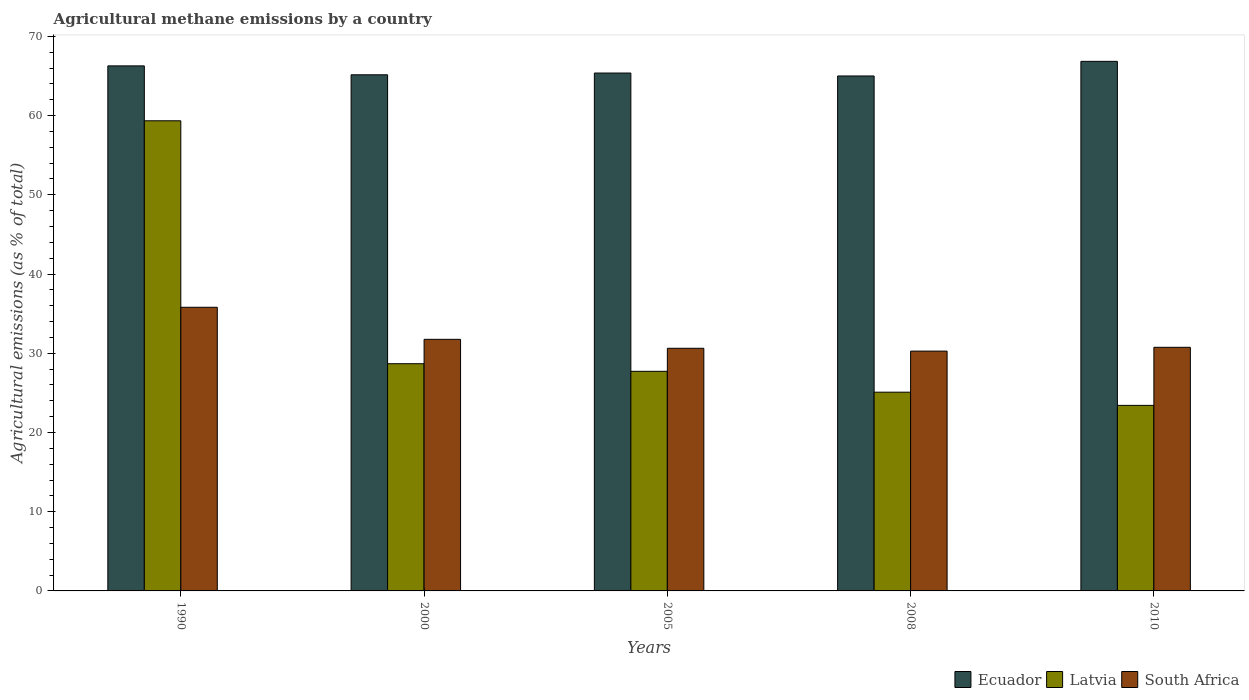How many different coloured bars are there?
Your answer should be very brief. 3. How many groups of bars are there?
Offer a very short reply. 5. Are the number of bars on each tick of the X-axis equal?
Your answer should be very brief. Yes. How many bars are there on the 2nd tick from the right?
Keep it short and to the point. 3. What is the label of the 1st group of bars from the left?
Offer a very short reply. 1990. What is the amount of agricultural methane emitted in Ecuador in 2005?
Offer a terse response. 65.37. Across all years, what is the maximum amount of agricultural methane emitted in Ecuador?
Your response must be concise. 66.85. Across all years, what is the minimum amount of agricultural methane emitted in South Africa?
Provide a succinct answer. 30.27. In which year was the amount of agricultural methane emitted in Ecuador maximum?
Offer a terse response. 2010. In which year was the amount of agricultural methane emitted in South Africa minimum?
Provide a short and direct response. 2008. What is the total amount of agricultural methane emitted in Ecuador in the graph?
Offer a terse response. 328.64. What is the difference between the amount of agricultural methane emitted in South Africa in 1990 and that in 2005?
Your answer should be compact. 5.18. What is the difference between the amount of agricultural methane emitted in South Africa in 2000 and the amount of agricultural methane emitted in Ecuador in 2010?
Provide a short and direct response. -35.09. What is the average amount of agricultural methane emitted in Ecuador per year?
Make the answer very short. 65.73. In the year 2000, what is the difference between the amount of agricultural methane emitted in Latvia and amount of agricultural methane emitted in Ecuador?
Offer a terse response. -36.47. In how many years, is the amount of agricultural methane emitted in South Africa greater than 32 %?
Make the answer very short. 1. What is the ratio of the amount of agricultural methane emitted in Latvia in 2000 to that in 2010?
Offer a very short reply. 1.22. Is the amount of agricultural methane emitted in Latvia in 2005 less than that in 2008?
Offer a terse response. No. Is the difference between the amount of agricultural methane emitted in Latvia in 2008 and 2010 greater than the difference between the amount of agricultural methane emitted in Ecuador in 2008 and 2010?
Provide a short and direct response. Yes. What is the difference between the highest and the second highest amount of agricultural methane emitted in Ecuador?
Your answer should be compact. 0.57. What is the difference between the highest and the lowest amount of agricultural methane emitted in Ecuador?
Offer a very short reply. 1.85. What does the 1st bar from the left in 2005 represents?
Offer a very short reply. Ecuador. What does the 3rd bar from the right in 2005 represents?
Keep it short and to the point. Ecuador. Is it the case that in every year, the sum of the amount of agricultural methane emitted in Latvia and amount of agricultural methane emitted in South Africa is greater than the amount of agricultural methane emitted in Ecuador?
Your response must be concise. No. How many bars are there?
Keep it short and to the point. 15. How many years are there in the graph?
Keep it short and to the point. 5. What is the difference between two consecutive major ticks on the Y-axis?
Your response must be concise. 10. Are the values on the major ticks of Y-axis written in scientific E-notation?
Make the answer very short. No. How many legend labels are there?
Provide a short and direct response. 3. What is the title of the graph?
Provide a succinct answer. Agricultural methane emissions by a country. What is the label or title of the Y-axis?
Ensure brevity in your answer.  Agricultural emissions (as % of total). What is the Agricultural emissions (as % of total) of Ecuador in 1990?
Make the answer very short. 66.27. What is the Agricultural emissions (as % of total) in Latvia in 1990?
Your answer should be compact. 59.34. What is the Agricultural emissions (as % of total) of South Africa in 1990?
Provide a succinct answer. 35.8. What is the Agricultural emissions (as % of total) of Ecuador in 2000?
Give a very brief answer. 65.15. What is the Agricultural emissions (as % of total) in Latvia in 2000?
Provide a succinct answer. 28.68. What is the Agricultural emissions (as % of total) in South Africa in 2000?
Provide a succinct answer. 31.76. What is the Agricultural emissions (as % of total) in Ecuador in 2005?
Your response must be concise. 65.37. What is the Agricultural emissions (as % of total) of Latvia in 2005?
Your answer should be compact. 27.72. What is the Agricultural emissions (as % of total) of South Africa in 2005?
Offer a terse response. 30.63. What is the Agricultural emissions (as % of total) in Ecuador in 2008?
Your response must be concise. 65. What is the Agricultural emissions (as % of total) of Latvia in 2008?
Your answer should be very brief. 25.09. What is the Agricultural emissions (as % of total) of South Africa in 2008?
Keep it short and to the point. 30.27. What is the Agricultural emissions (as % of total) of Ecuador in 2010?
Offer a terse response. 66.85. What is the Agricultural emissions (as % of total) of Latvia in 2010?
Keep it short and to the point. 23.42. What is the Agricultural emissions (as % of total) in South Africa in 2010?
Ensure brevity in your answer.  30.75. Across all years, what is the maximum Agricultural emissions (as % of total) of Ecuador?
Provide a short and direct response. 66.85. Across all years, what is the maximum Agricultural emissions (as % of total) of Latvia?
Provide a short and direct response. 59.34. Across all years, what is the maximum Agricultural emissions (as % of total) in South Africa?
Offer a terse response. 35.8. Across all years, what is the minimum Agricultural emissions (as % of total) of Ecuador?
Keep it short and to the point. 65. Across all years, what is the minimum Agricultural emissions (as % of total) of Latvia?
Offer a very short reply. 23.42. Across all years, what is the minimum Agricultural emissions (as % of total) in South Africa?
Your answer should be very brief. 30.27. What is the total Agricultural emissions (as % of total) in Ecuador in the graph?
Provide a succinct answer. 328.64. What is the total Agricultural emissions (as % of total) of Latvia in the graph?
Provide a succinct answer. 164.25. What is the total Agricultural emissions (as % of total) of South Africa in the graph?
Offer a very short reply. 159.21. What is the difference between the Agricultural emissions (as % of total) of Ecuador in 1990 and that in 2000?
Ensure brevity in your answer.  1.12. What is the difference between the Agricultural emissions (as % of total) of Latvia in 1990 and that in 2000?
Offer a very short reply. 30.66. What is the difference between the Agricultural emissions (as % of total) of South Africa in 1990 and that in 2000?
Provide a short and direct response. 4.05. What is the difference between the Agricultural emissions (as % of total) of Ecuador in 1990 and that in 2005?
Provide a succinct answer. 0.9. What is the difference between the Agricultural emissions (as % of total) in Latvia in 1990 and that in 2005?
Provide a succinct answer. 31.62. What is the difference between the Agricultural emissions (as % of total) in South Africa in 1990 and that in 2005?
Provide a short and direct response. 5.18. What is the difference between the Agricultural emissions (as % of total) in Ecuador in 1990 and that in 2008?
Your answer should be very brief. 1.27. What is the difference between the Agricultural emissions (as % of total) of Latvia in 1990 and that in 2008?
Your response must be concise. 34.26. What is the difference between the Agricultural emissions (as % of total) in South Africa in 1990 and that in 2008?
Your answer should be very brief. 5.53. What is the difference between the Agricultural emissions (as % of total) of Ecuador in 1990 and that in 2010?
Give a very brief answer. -0.57. What is the difference between the Agricultural emissions (as % of total) of Latvia in 1990 and that in 2010?
Give a very brief answer. 35.92. What is the difference between the Agricultural emissions (as % of total) of South Africa in 1990 and that in 2010?
Your answer should be compact. 5.05. What is the difference between the Agricultural emissions (as % of total) in Ecuador in 2000 and that in 2005?
Your answer should be very brief. -0.22. What is the difference between the Agricultural emissions (as % of total) of Latvia in 2000 and that in 2005?
Your response must be concise. 0.96. What is the difference between the Agricultural emissions (as % of total) of South Africa in 2000 and that in 2005?
Your answer should be compact. 1.13. What is the difference between the Agricultural emissions (as % of total) of Ecuador in 2000 and that in 2008?
Your answer should be compact. 0.15. What is the difference between the Agricultural emissions (as % of total) of Latvia in 2000 and that in 2008?
Make the answer very short. 3.59. What is the difference between the Agricultural emissions (as % of total) of South Africa in 2000 and that in 2008?
Offer a terse response. 1.49. What is the difference between the Agricultural emissions (as % of total) of Ecuador in 2000 and that in 2010?
Provide a short and direct response. -1.7. What is the difference between the Agricultural emissions (as % of total) in Latvia in 2000 and that in 2010?
Make the answer very short. 5.26. What is the difference between the Agricultural emissions (as % of total) of South Africa in 2000 and that in 2010?
Your answer should be compact. 1.01. What is the difference between the Agricultural emissions (as % of total) in Ecuador in 2005 and that in 2008?
Offer a very short reply. 0.37. What is the difference between the Agricultural emissions (as % of total) of Latvia in 2005 and that in 2008?
Make the answer very short. 2.63. What is the difference between the Agricultural emissions (as % of total) of South Africa in 2005 and that in 2008?
Your answer should be very brief. 0.36. What is the difference between the Agricultural emissions (as % of total) in Ecuador in 2005 and that in 2010?
Provide a succinct answer. -1.48. What is the difference between the Agricultural emissions (as % of total) of Latvia in 2005 and that in 2010?
Provide a short and direct response. 4.3. What is the difference between the Agricultural emissions (as % of total) in South Africa in 2005 and that in 2010?
Ensure brevity in your answer.  -0.12. What is the difference between the Agricultural emissions (as % of total) of Ecuador in 2008 and that in 2010?
Your answer should be very brief. -1.85. What is the difference between the Agricultural emissions (as % of total) of Latvia in 2008 and that in 2010?
Your response must be concise. 1.67. What is the difference between the Agricultural emissions (as % of total) in South Africa in 2008 and that in 2010?
Your answer should be very brief. -0.48. What is the difference between the Agricultural emissions (as % of total) in Ecuador in 1990 and the Agricultural emissions (as % of total) in Latvia in 2000?
Keep it short and to the point. 37.59. What is the difference between the Agricultural emissions (as % of total) of Ecuador in 1990 and the Agricultural emissions (as % of total) of South Africa in 2000?
Ensure brevity in your answer.  34.52. What is the difference between the Agricultural emissions (as % of total) of Latvia in 1990 and the Agricultural emissions (as % of total) of South Africa in 2000?
Provide a short and direct response. 27.59. What is the difference between the Agricultural emissions (as % of total) of Ecuador in 1990 and the Agricultural emissions (as % of total) of Latvia in 2005?
Your answer should be compact. 38.55. What is the difference between the Agricultural emissions (as % of total) of Ecuador in 1990 and the Agricultural emissions (as % of total) of South Africa in 2005?
Provide a succinct answer. 35.65. What is the difference between the Agricultural emissions (as % of total) of Latvia in 1990 and the Agricultural emissions (as % of total) of South Africa in 2005?
Ensure brevity in your answer.  28.72. What is the difference between the Agricultural emissions (as % of total) of Ecuador in 1990 and the Agricultural emissions (as % of total) of Latvia in 2008?
Provide a succinct answer. 41.19. What is the difference between the Agricultural emissions (as % of total) in Ecuador in 1990 and the Agricultural emissions (as % of total) in South Africa in 2008?
Provide a succinct answer. 36. What is the difference between the Agricultural emissions (as % of total) of Latvia in 1990 and the Agricultural emissions (as % of total) of South Africa in 2008?
Keep it short and to the point. 29.07. What is the difference between the Agricultural emissions (as % of total) in Ecuador in 1990 and the Agricultural emissions (as % of total) in Latvia in 2010?
Your answer should be very brief. 42.85. What is the difference between the Agricultural emissions (as % of total) in Ecuador in 1990 and the Agricultural emissions (as % of total) in South Africa in 2010?
Provide a succinct answer. 35.52. What is the difference between the Agricultural emissions (as % of total) of Latvia in 1990 and the Agricultural emissions (as % of total) of South Africa in 2010?
Offer a terse response. 28.59. What is the difference between the Agricultural emissions (as % of total) of Ecuador in 2000 and the Agricultural emissions (as % of total) of Latvia in 2005?
Offer a terse response. 37.43. What is the difference between the Agricultural emissions (as % of total) of Ecuador in 2000 and the Agricultural emissions (as % of total) of South Africa in 2005?
Offer a very short reply. 34.52. What is the difference between the Agricultural emissions (as % of total) in Latvia in 2000 and the Agricultural emissions (as % of total) in South Africa in 2005?
Offer a very short reply. -1.95. What is the difference between the Agricultural emissions (as % of total) in Ecuador in 2000 and the Agricultural emissions (as % of total) in Latvia in 2008?
Your answer should be very brief. 40.06. What is the difference between the Agricultural emissions (as % of total) of Ecuador in 2000 and the Agricultural emissions (as % of total) of South Africa in 2008?
Your answer should be very brief. 34.88. What is the difference between the Agricultural emissions (as % of total) in Latvia in 2000 and the Agricultural emissions (as % of total) in South Africa in 2008?
Provide a short and direct response. -1.59. What is the difference between the Agricultural emissions (as % of total) of Ecuador in 2000 and the Agricultural emissions (as % of total) of Latvia in 2010?
Provide a short and direct response. 41.73. What is the difference between the Agricultural emissions (as % of total) of Ecuador in 2000 and the Agricultural emissions (as % of total) of South Africa in 2010?
Your answer should be compact. 34.4. What is the difference between the Agricultural emissions (as % of total) of Latvia in 2000 and the Agricultural emissions (as % of total) of South Africa in 2010?
Offer a terse response. -2.07. What is the difference between the Agricultural emissions (as % of total) in Ecuador in 2005 and the Agricultural emissions (as % of total) in Latvia in 2008?
Your response must be concise. 40.28. What is the difference between the Agricultural emissions (as % of total) in Ecuador in 2005 and the Agricultural emissions (as % of total) in South Africa in 2008?
Ensure brevity in your answer.  35.1. What is the difference between the Agricultural emissions (as % of total) in Latvia in 2005 and the Agricultural emissions (as % of total) in South Africa in 2008?
Ensure brevity in your answer.  -2.55. What is the difference between the Agricultural emissions (as % of total) in Ecuador in 2005 and the Agricultural emissions (as % of total) in Latvia in 2010?
Make the answer very short. 41.95. What is the difference between the Agricultural emissions (as % of total) of Ecuador in 2005 and the Agricultural emissions (as % of total) of South Africa in 2010?
Your answer should be compact. 34.62. What is the difference between the Agricultural emissions (as % of total) of Latvia in 2005 and the Agricultural emissions (as % of total) of South Africa in 2010?
Provide a succinct answer. -3.03. What is the difference between the Agricultural emissions (as % of total) in Ecuador in 2008 and the Agricultural emissions (as % of total) in Latvia in 2010?
Give a very brief answer. 41.58. What is the difference between the Agricultural emissions (as % of total) in Ecuador in 2008 and the Agricultural emissions (as % of total) in South Africa in 2010?
Your answer should be compact. 34.25. What is the difference between the Agricultural emissions (as % of total) in Latvia in 2008 and the Agricultural emissions (as % of total) in South Africa in 2010?
Your response must be concise. -5.66. What is the average Agricultural emissions (as % of total) in Ecuador per year?
Make the answer very short. 65.73. What is the average Agricultural emissions (as % of total) in Latvia per year?
Give a very brief answer. 32.85. What is the average Agricultural emissions (as % of total) of South Africa per year?
Provide a succinct answer. 31.84. In the year 1990, what is the difference between the Agricultural emissions (as % of total) in Ecuador and Agricultural emissions (as % of total) in Latvia?
Keep it short and to the point. 6.93. In the year 1990, what is the difference between the Agricultural emissions (as % of total) in Ecuador and Agricultural emissions (as % of total) in South Africa?
Ensure brevity in your answer.  30.47. In the year 1990, what is the difference between the Agricultural emissions (as % of total) in Latvia and Agricultural emissions (as % of total) in South Africa?
Your response must be concise. 23.54. In the year 2000, what is the difference between the Agricultural emissions (as % of total) in Ecuador and Agricultural emissions (as % of total) in Latvia?
Offer a terse response. 36.47. In the year 2000, what is the difference between the Agricultural emissions (as % of total) in Ecuador and Agricultural emissions (as % of total) in South Africa?
Provide a succinct answer. 33.39. In the year 2000, what is the difference between the Agricultural emissions (as % of total) of Latvia and Agricultural emissions (as % of total) of South Africa?
Your answer should be very brief. -3.08. In the year 2005, what is the difference between the Agricultural emissions (as % of total) in Ecuador and Agricultural emissions (as % of total) in Latvia?
Ensure brevity in your answer.  37.65. In the year 2005, what is the difference between the Agricultural emissions (as % of total) in Ecuador and Agricultural emissions (as % of total) in South Africa?
Provide a succinct answer. 34.74. In the year 2005, what is the difference between the Agricultural emissions (as % of total) of Latvia and Agricultural emissions (as % of total) of South Africa?
Provide a short and direct response. -2.91. In the year 2008, what is the difference between the Agricultural emissions (as % of total) of Ecuador and Agricultural emissions (as % of total) of Latvia?
Your response must be concise. 39.91. In the year 2008, what is the difference between the Agricultural emissions (as % of total) in Ecuador and Agricultural emissions (as % of total) in South Africa?
Keep it short and to the point. 34.73. In the year 2008, what is the difference between the Agricultural emissions (as % of total) of Latvia and Agricultural emissions (as % of total) of South Africa?
Make the answer very short. -5.18. In the year 2010, what is the difference between the Agricultural emissions (as % of total) in Ecuador and Agricultural emissions (as % of total) in Latvia?
Your answer should be compact. 43.43. In the year 2010, what is the difference between the Agricultural emissions (as % of total) in Ecuador and Agricultural emissions (as % of total) in South Africa?
Your answer should be compact. 36.1. In the year 2010, what is the difference between the Agricultural emissions (as % of total) in Latvia and Agricultural emissions (as % of total) in South Africa?
Your answer should be very brief. -7.33. What is the ratio of the Agricultural emissions (as % of total) in Ecuador in 1990 to that in 2000?
Give a very brief answer. 1.02. What is the ratio of the Agricultural emissions (as % of total) in Latvia in 1990 to that in 2000?
Provide a short and direct response. 2.07. What is the ratio of the Agricultural emissions (as % of total) of South Africa in 1990 to that in 2000?
Your answer should be very brief. 1.13. What is the ratio of the Agricultural emissions (as % of total) in Ecuador in 1990 to that in 2005?
Ensure brevity in your answer.  1.01. What is the ratio of the Agricultural emissions (as % of total) of Latvia in 1990 to that in 2005?
Give a very brief answer. 2.14. What is the ratio of the Agricultural emissions (as % of total) in South Africa in 1990 to that in 2005?
Your response must be concise. 1.17. What is the ratio of the Agricultural emissions (as % of total) in Ecuador in 1990 to that in 2008?
Provide a short and direct response. 1.02. What is the ratio of the Agricultural emissions (as % of total) in Latvia in 1990 to that in 2008?
Provide a succinct answer. 2.37. What is the ratio of the Agricultural emissions (as % of total) in South Africa in 1990 to that in 2008?
Make the answer very short. 1.18. What is the ratio of the Agricultural emissions (as % of total) in Latvia in 1990 to that in 2010?
Give a very brief answer. 2.53. What is the ratio of the Agricultural emissions (as % of total) in South Africa in 1990 to that in 2010?
Keep it short and to the point. 1.16. What is the ratio of the Agricultural emissions (as % of total) of Latvia in 2000 to that in 2005?
Your answer should be very brief. 1.03. What is the ratio of the Agricultural emissions (as % of total) of South Africa in 2000 to that in 2005?
Your answer should be very brief. 1.04. What is the ratio of the Agricultural emissions (as % of total) of Ecuador in 2000 to that in 2008?
Provide a succinct answer. 1. What is the ratio of the Agricultural emissions (as % of total) of Latvia in 2000 to that in 2008?
Provide a short and direct response. 1.14. What is the ratio of the Agricultural emissions (as % of total) of South Africa in 2000 to that in 2008?
Keep it short and to the point. 1.05. What is the ratio of the Agricultural emissions (as % of total) in Ecuador in 2000 to that in 2010?
Give a very brief answer. 0.97. What is the ratio of the Agricultural emissions (as % of total) of Latvia in 2000 to that in 2010?
Give a very brief answer. 1.22. What is the ratio of the Agricultural emissions (as % of total) of South Africa in 2000 to that in 2010?
Your answer should be compact. 1.03. What is the ratio of the Agricultural emissions (as % of total) in Latvia in 2005 to that in 2008?
Offer a very short reply. 1.1. What is the ratio of the Agricultural emissions (as % of total) in South Africa in 2005 to that in 2008?
Provide a succinct answer. 1.01. What is the ratio of the Agricultural emissions (as % of total) in Ecuador in 2005 to that in 2010?
Offer a terse response. 0.98. What is the ratio of the Agricultural emissions (as % of total) in Latvia in 2005 to that in 2010?
Your answer should be very brief. 1.18. What is the ratio of the Agricultural emissions (as % of total) in Ecuador in 2008 to that in 2010?
Offer a terse response. 0.97. What is the ratio of the Agricultural emissions (as % of total) of Latvia in 2008 to that in 2010?
Keep it short and to the point. 1.07. What is the ratio of the Agricultural emissions (as % of total) in South Africa in 2008 to that in 2010?
Your answer should be very brief. 0.98. What is the difference between the highest and the second highest Agricultural emissions (as % of total) of Ecuador?
Ensure brevity in your answer.  0.57. What is the difference between the highest and the second highest Agricultural emissions (as % of total) in Latvia?
Provide a short and direct response. 30.66. What is the difference between the highest and the second highest Agricultural emissions (as % of total) of South Africa?
Keep it short and to the point. 4.05. What is the difference between the highest and the lowest Agricultural emissions (as % of total) of Ecuador?
Give a very brief answer. 1.85. What is the difference between the highest and the lowest Agricultural emissions (as % of total) of Latvia?
Offer a terse response. 35.92. What is the difference between the highest and the lowest Agricultural emissions (as % of total) of South Africa?
Provide a succinct answer. 5.53. 